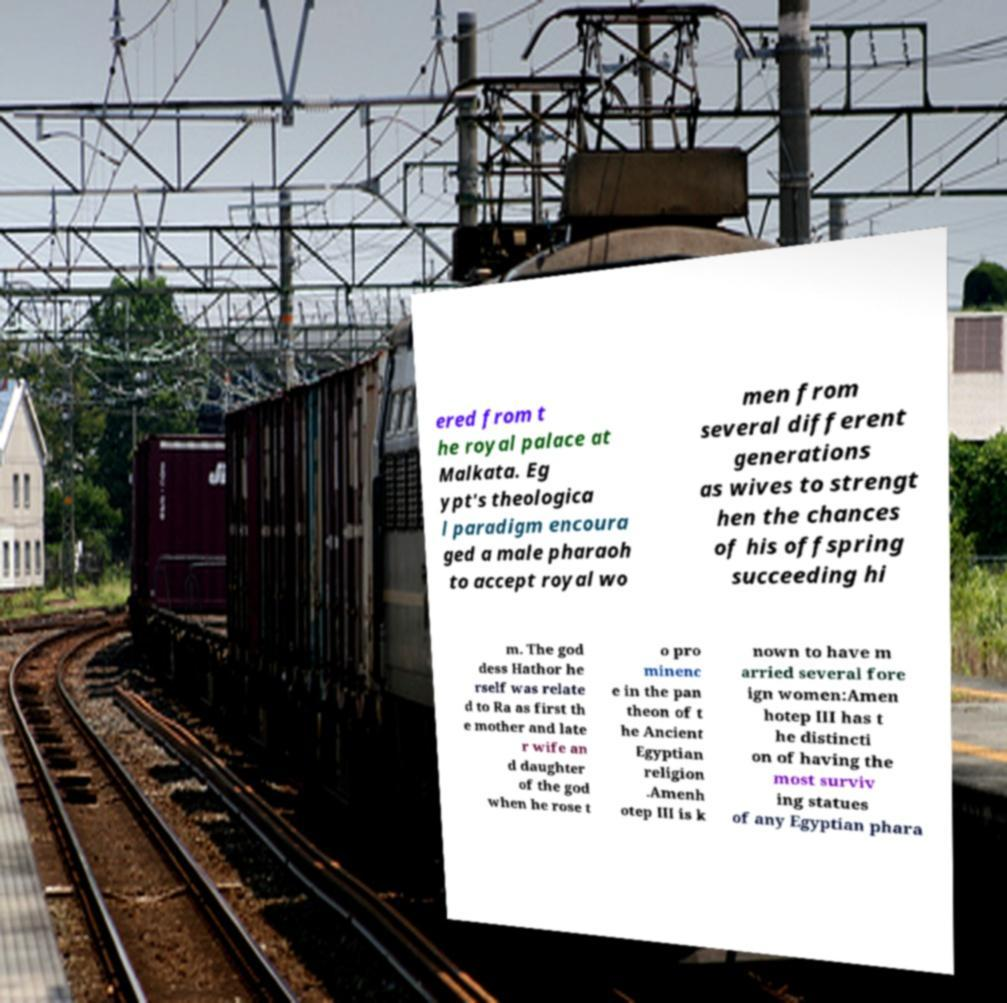There's text embedded in this image that I need extracted. Can you transcribe it verbatim? ered from t he royal palace at Malkata. Eg ypt's theologica l paradigm encoura ged a male pharaoh to accept royal wo men from several different generations as wives to strengt hen the chances of his offspring succeeding hi m. The god dess Hathor he rself was relate d to Ra as first th e mother and late r wife an d daughter of the god when he rose t o pro minenc e in the pan theon of t he Ancient Egyptian religion .Amenh otep III is k nown to have m arried several fore ign women:Amen hotep III has t he distincti on of having the most surviv ing statues of any Egyptian phara 